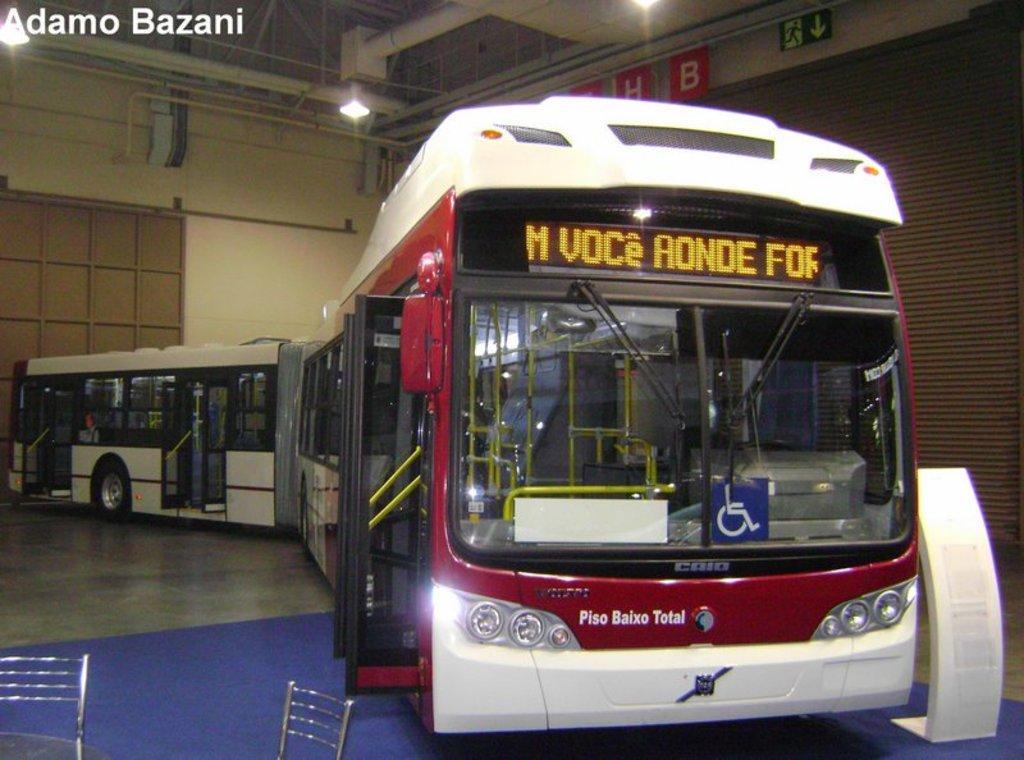Can you describe this image briefly? In this image I can see a bi- articulated bus. I can see the rooftop with some pipes and lights. On the right hand side of the image I can see a shutter with some sign boards at the top. In the bottom left corner I can see some chairs. In the top left corner I can see some text. 